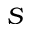<formula> <loc_0><loc_0><loc_500><loc_500>S</formula> 